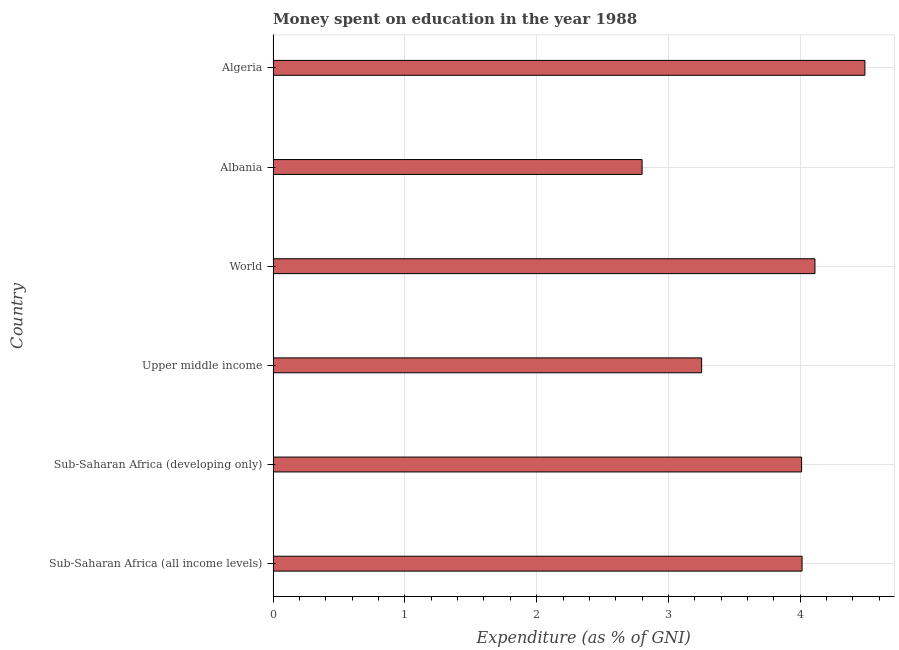Does the graph contain any zero values?
Provide a short and direct response. No. Does the graph contain grids?
Provide a succinct answer. Yes. What is the title of the graph?
Your answer should be very brief. Money spent on education in the year 1988. What is the label or title of the X-axis?
Keep it short and to the point. Expenditure (as % of GNI). What is the expenditure on education in World?
Offer a very short reply. 4.11. Across all countries, what is the maximum expenditure on education?
Give a very brief answer. 4.49. In which country was the expenditure on education maximum?
Your response must be concise. Algeria. In which country was the expenditure on education minimum?
Provide a short and direct response. Albania. What is the sum of the expenditure on education?
Offer a terse response. 22.68. What is the difference between the expenditure on education in Algeria and Upper middle income?
Your answer should be very brief. 1.24. What is the average expenditure on education per country?
Offer a terse response. 3.78. What is the median expenditure on education?
Your answer should be very brief. 4.01. In how many countries, is the expenditure on education greater than 1.4 %?
Ensure brevity in your answer.  6. Is the expenditure on education in Albania less than that in Upper middle income?
Ensure brevity in your answer.  Yes. Is the difference between the expenditure on education in Albania and Algeria greater than the difference between any two countries?
Ensure brevity in your answer.  Yes. What is the difference between the highest and the second highest expenditure on education?
Your response must be concise. 0.38. What is the difference between the highest and the lowest expenditure on education?
Offer a terse response. 1.69. How many bars are there?
Make the answer very short. 6. Are all the bars in the graph horizontal?
Your answer should be very brief. Yes. How many countries are there in the graph?
Your response must be concise. 6. Are the values on the major ticks of X-axis written in scientific E-notation?
Your answer should be very brief. No. What is the Expenditure (as % of GNI) of Sub-Saharan Africa (all income levels)?
Your answer should be compact. 4.01. What is the Expenditure (as % of GNI) in Sub-Saharan Africa (developing only)?
Your answer should be compact. 4.01. What is the Expenditure (as % of GNI) in Upper middle income?
Provide a succinct answer. 3.25. What is the Expenditure (as % of GNI) in World?
Provide a short and direct response. 4.11. What is the Expenditure (as % of GNI) of Albania?
Provide a short and direct response. 2.8. What is the Expenditure (as % of GNI) of Algeria?
Make the answer very short. 4.49. What is the difference between the Expenditure (as % of GNI) in Sub-Saharan Africa (all income levels) and Sub-Saharan Africa (developing only)?
Your answer should be compact. 0. What is the difference between the Expenditure (as % of GNI) in Sub-Saharan Africa (all income levels) and Upper middle income?
Your response must be concise. 0.76. What is the difference between the Expenditure (as % of GNI) in Sub-Saharan Africa (all income levels) and World?
Your response must be concise. -0.1. What is the difference between the Expenditure (as % of GNI) in Sub-Saharan Africa (all income levels) and Albania?
Keep it short and to the point. 1.21. What is the difference between the Expenditure (as % of GNI) in Sub-Saharan Africa (all income levels) and Algeria?
Give a very brief answer. -0.48. What is the difference between the Expenditure (as % of GNI) in Sub-Saharan Africa (developing only) and Upper middle income?
Your response must be concise. 0.76. What is the difference between the Expenditure (as % of GNI) in Sub-Saharan Africa (developing only) and World?
Provide a succinct answer. -0.1. What is the difference between the Expenditure (as % of GNI) in Sub-Saharan Africa (developing only) and Albania?
Provide a succinct answer. 1.21. What is the difference between the Expenditure (as % of GNI) in Sub-Saharan Africa (developing only) and Algeria?
Make the answer very short. -0.48. What is the difference between the Expenditure (as % of GNI) in Upper middle income and World?
Offer a very short reply. -0.86. What is the difference between the Expenditure (as % of GNI) in Upper middle income and Albania?
Offer a very short reply. 0.45. What is the difference between the Expenditure (as % of GNI) in Upper middle income and Algeria?
Offer a very short reply. -1.24. What is the difference between the Expenditure (as % of GNI) in World and Albania?
Your response must be concise. 1.31. What is the difference between the Expenditure (as % of GNI) in World and Algeria?
Your answer should be very brief. -0.38. What is the difference between the Expenditure (as % of GNI) in Albania and Algeria?
Make the answer very short. -1.69. What is the ratio of the Expenditure (as % of GNI) in Sub-Saharan Africa (all income levels) to that in Upper middle income?
Offer a very short reply. 1.23. What is the ratio of the Expenditure (as % of GNI) in Sub-Saharan Africa (all income levels) to that in Albania?
Offer a very short reply. 1.43. What is the ratio of the Expenditure (as % of GNI) in Sub-Saharan Africa (all income levels) to that in Algeria?
Offer a very short reply. 0.89. What is the ratio of the Expenditure (as % of GNI) in Sub-Saharan Africa (developing only) to that in Upper middle income?
Make the answer very short. 1.23. What is the ratio of the Expenditure (as % of GNI) in Sub-Saharan Africa (developing only) to that in Albania?
Make the answer very short. 1.43. What is the ratio of the Expenditure (as % of GNI) in Sub-Saharan Africa (developing only) to that in Algeria?
Make the answer very short. 0.89. What is the ratio of the Expenditure (as % of GNI) in Upper middle income to that in World?
Offer a terse response. 0.79. What is the ratio of the Expenditure (as % of GNI) in Upper middle income to that in Albania?
Your answer should be very brief. 1.16. What is the ratio of the Expenditure (as % of GNI) in Upper middle income to that in Algeria?
Your answer should be compact. 0.72. What is the ratio of the Expenditure (as % of GNI) in World to that in Albania?
Give a very brief answer. 1.47. What is the ratio of the Expenditure (as % of GNI) in World to that in Algeria?
Keep it short and to the point. 0.92. What is the ratio of the Expenditure (as % of GNI) in Albania to that in Algeria?
Provide a succinct answer. 0.62. 